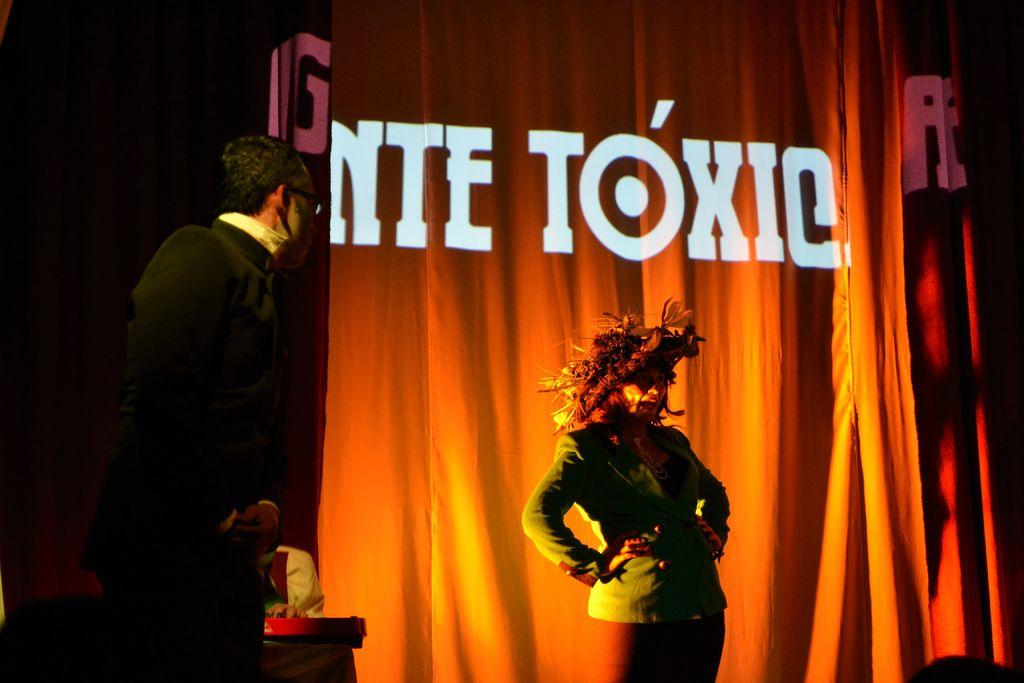Who are the people in the image? There is a man and a woman in the image. What are the man and woman doing in the image? Both the man and woman are standing on a dais. What is the woman wearing on her head? The woman is wearing a cap on her head. What can be seen in the image besides the man and woman? There is a cloth with text visible in the image. What type of bears can be seen interacting with the governor in the image? There are no bears or governor present in the image. How does the image relate to historical events? The image does not provide any information about historical events. 